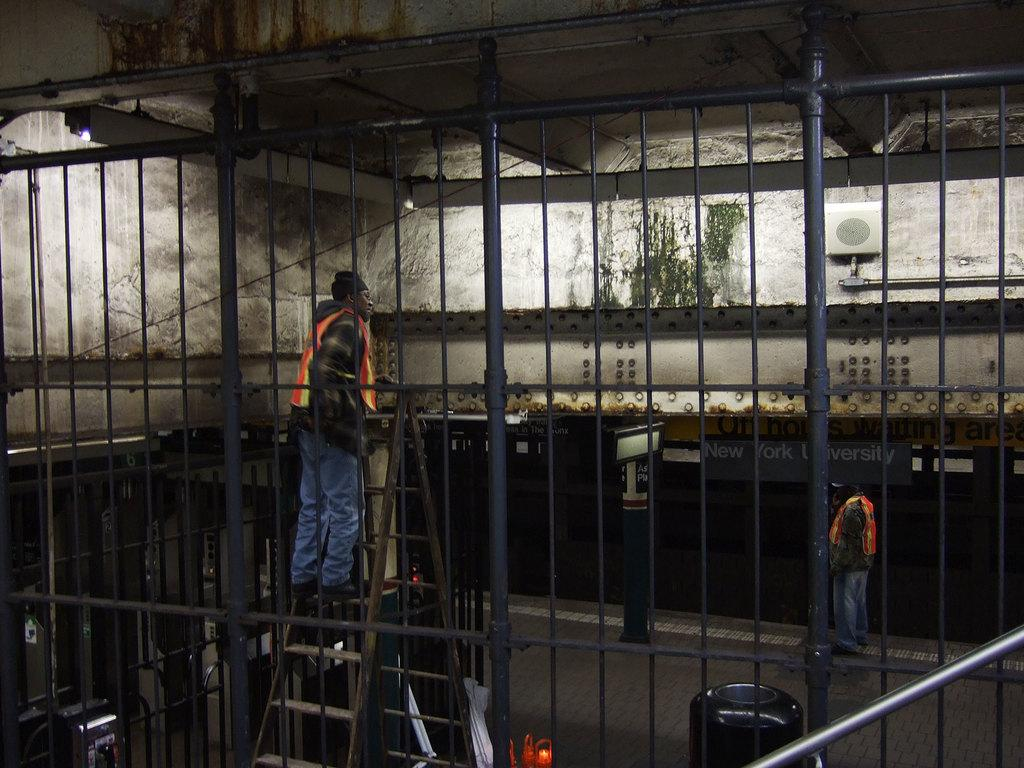What type of structure can be seen in the image? There is a railing in the image. How many people are present in the image? There are two people in the image. What other object can be seen in the image? There is a ladder in the image. What is visible in the background of the image? There is a board and a building in the background of the image. Can you see any flowers growing near the ladder in the image? There are no flowers visible in the image; it primarily features a railing, two people, a ladder, and a background with a board and a building. 